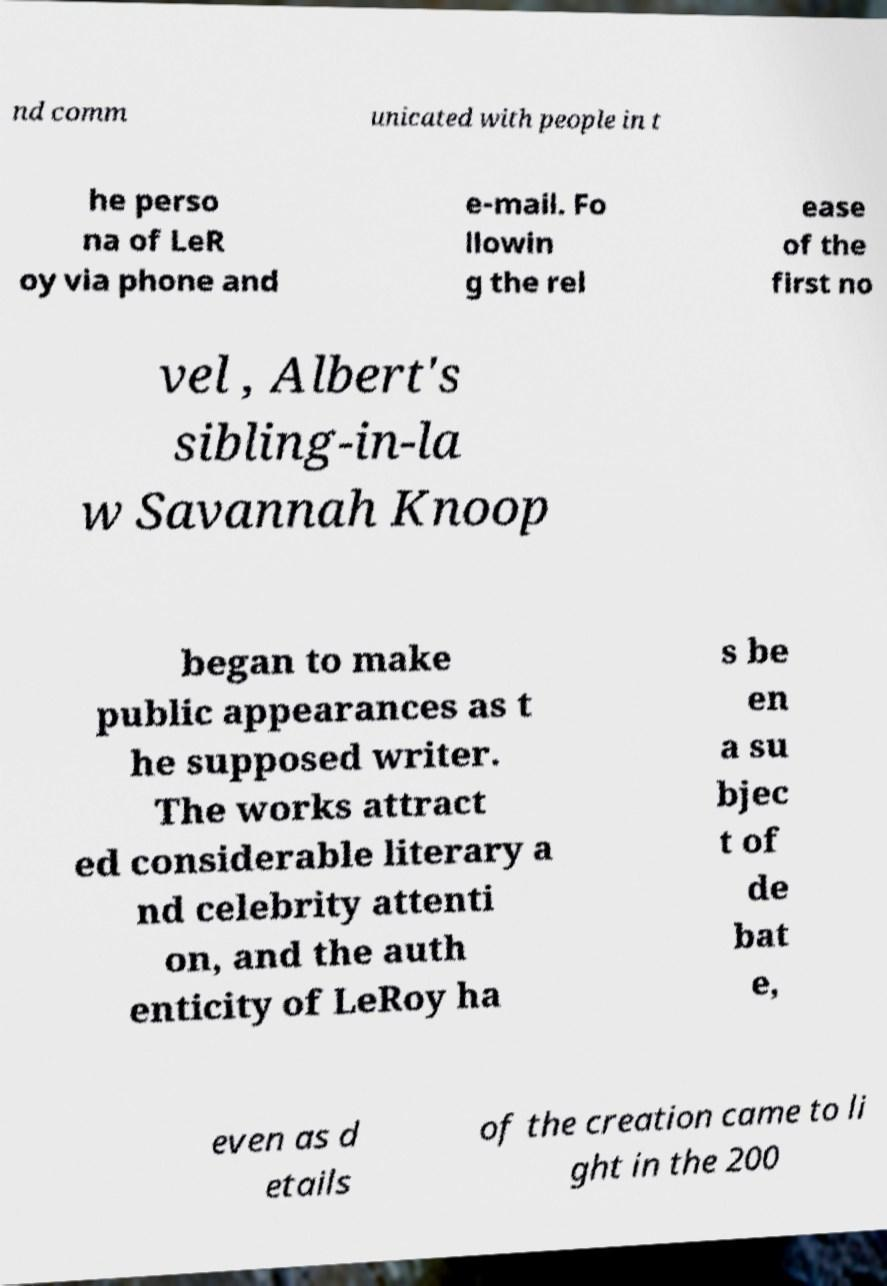Can you accurately transcribe the text from the provided image for me? nd comm unicated with people in t he perso na of LeR oy via phone and e-mail. Fo llowin g the rel ease of the first no vel , Albert's sibling-in-la w Savannah Knoop began to make public appearances as t he supposed writer. The works attract ed considerable literary a nd celebrity attenti on, and the auth enticity of LeRoy ha s be en a su bjec t of de bat e, even as d etails of the creation came to li ght in the 200 